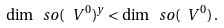<formula> <loc_0><loc_0><loc_500><loc_500>\dim \ s o ( \ V ^ { 0 } ) ^ { y } < \dim \ s o ( \ V ^ { 0 } ) \, .</formula> 